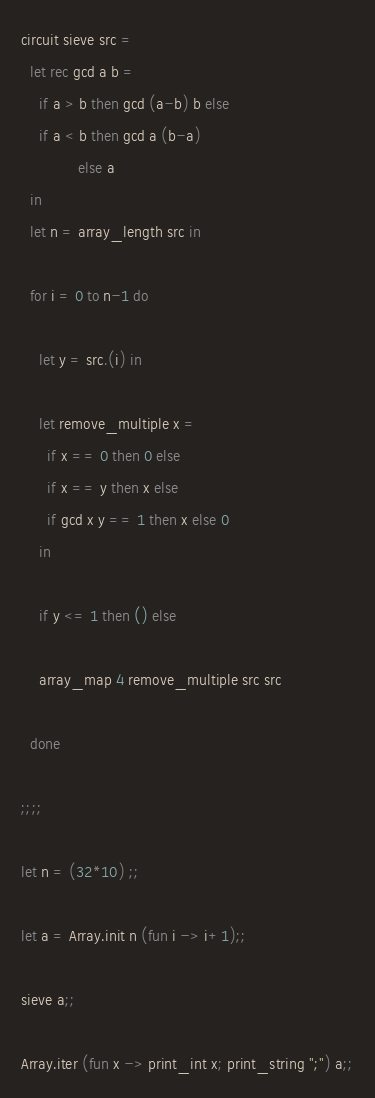<code> <loc_0><loc_0><loc_500><loc_500><_OCaml_>circuit sieve src =
  let rec gcd a b =
    if a > b then gcd (a-b) b else 
    if a < b then gcd a (b-a)
             else a
  in
  let n = array_length src in

  for i = 0 to n-1 do

    let y = src.(i) in

    let remove_multiple x = 
      if x == 0 then 0 else 
      if x == y then x else 
      if gcd x y == 1 then x else 0
    in
    
    if y <= 1 then () else
    
    array_map 4 remove_multiple src src

  done

;;;;

let n = (32*10) ;;

let a = Array.init n (fun i -> i+1);;

sieve a;;

Array.iter (fun x -> print_int x; print_string ";") a;;
</code> 